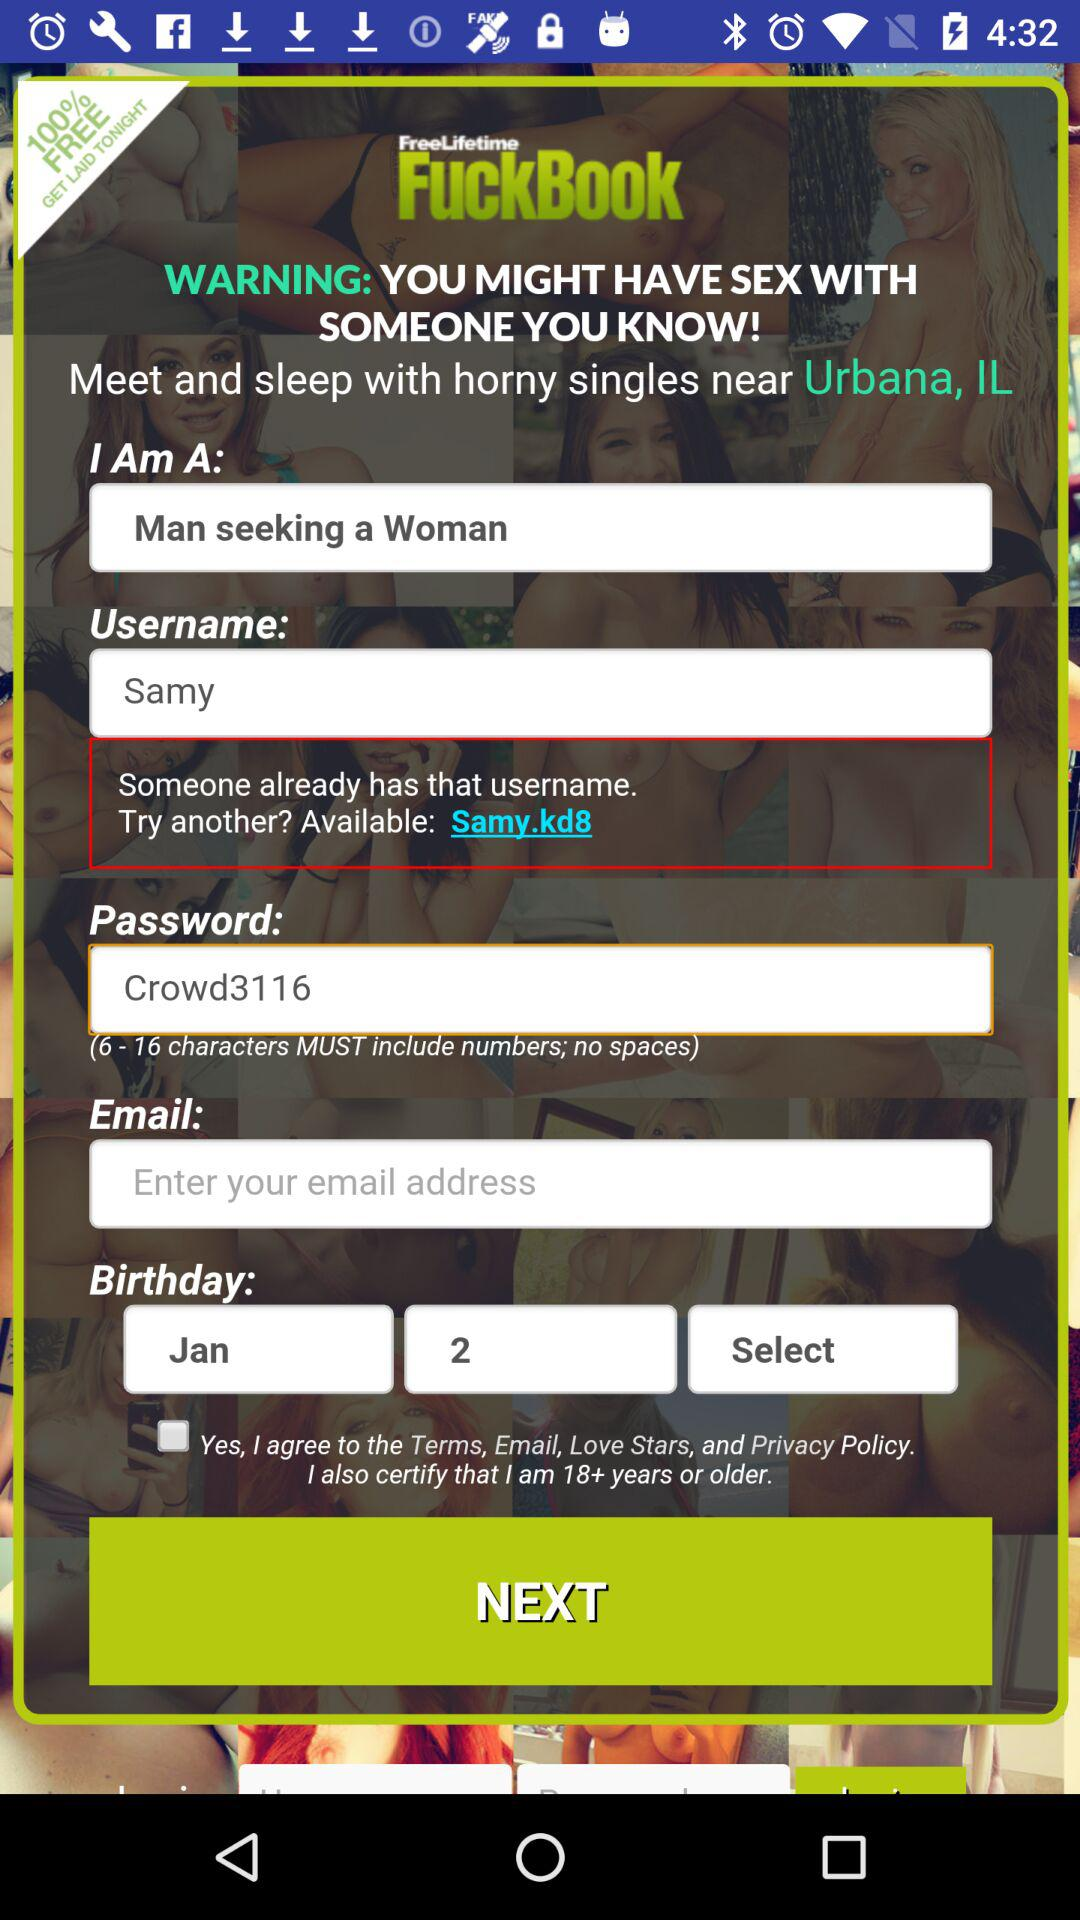What does the user seeking for? The user is seeking a woman. 